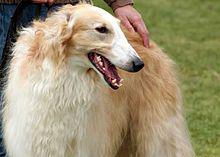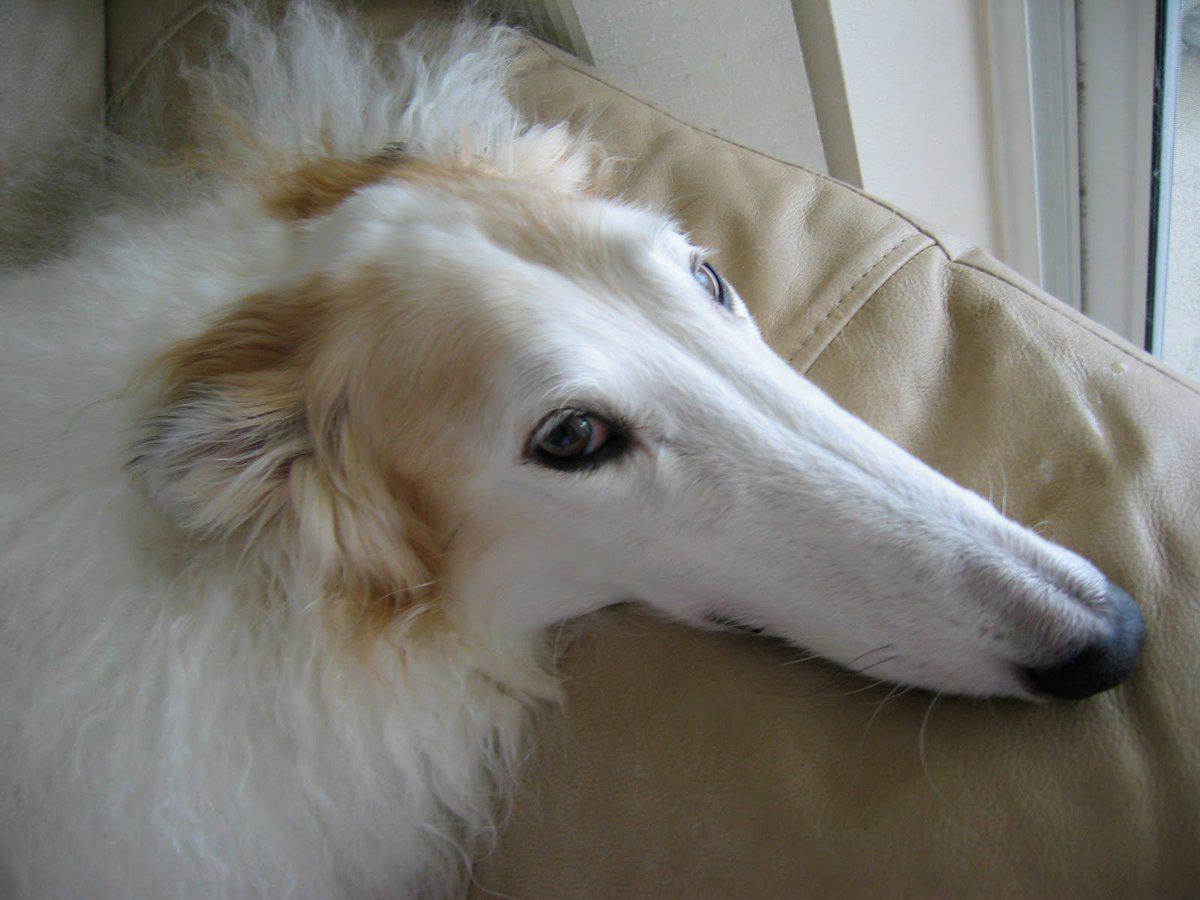The first image is the image on the left, the second image is the image on the right. Examine the images to the left and right. Is the description "More than one quarter of the dogs has their mouth open." accurate? Answer yes or no. Yes. The first image is the image on the left, the second image is the image on the right. Analyze the images presented: Is the assertion "There are at most two dogs." valid? Answer yes or no. Yes. 